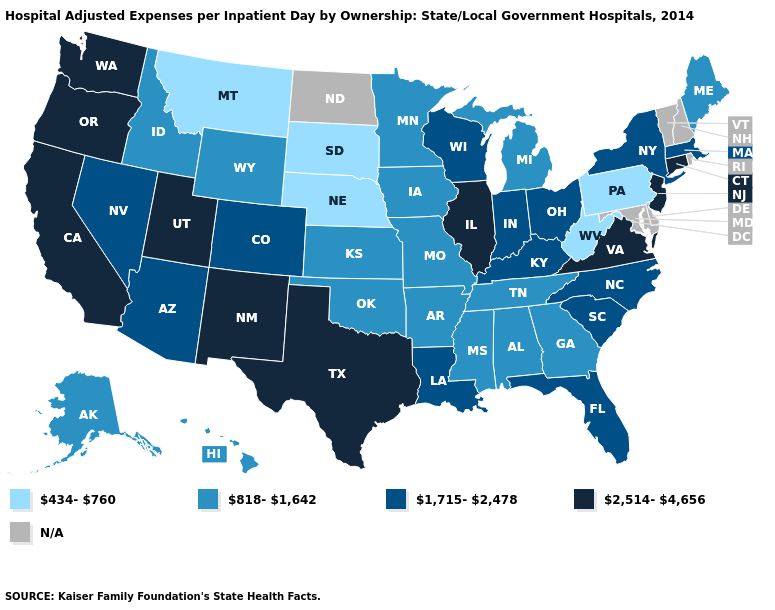Does the map have missing data?
Write a very short answer. Yes. What is the highest value in states that border Arkansas?
Be succinct. 2,514-4,656. What is the lowest value in states that border Tennessee?
Answer briefly. 818-1,642. Which states have the lowest value in the USA?
Give a very brief answer. Montana, Nebraska, Pennsylvania, South Dakota, West Virginia. Among the states that border Utah , does Nevada have the lowest value?
Concise answer only. No. What is the value of Arizona?
Answer briefly. 1,715-2,478. What is the value of New York?
Be succinct. 1,715-2,478. Which states have the highest value in the USA?
Keep it brief. California, Connecticut, Illinois, New Jersey, New Mexico, Oregon, Texas, Utah, Virginia, Washington. How many symbols are there in the legend?
Short answer required. 5. Does Arizona have the lowest value in the West?
Short answer required. No. Name the states that have a value in the range N/A?
Answer briefly. Delaware, Maryland, New Hampshire, North Dakota, Rhode Island, Vermont. What is the highest value in the USA?
Give a very brief answer. 2,514-4,656. Name the states that have a value in the range 2,514-4,656?
Concise answer only. California, Connecticut, Illinois, New Jersey, New Mexico, Oregon, Texas, Utah, Virginia, Washington. Name the states that have a value in the range 818-1,642?
Keep it brief. Alabama, Alaska, Arkansas, Georgia, Hawaii, Idaho, Iowa, Kansas, Maine, Michigan, Minnesota, Mississippi, Missouri, Oklahoma, Tennessee, Wyoming. What is the value of Nevada?
Keep it brief. 1,715-2,478. 